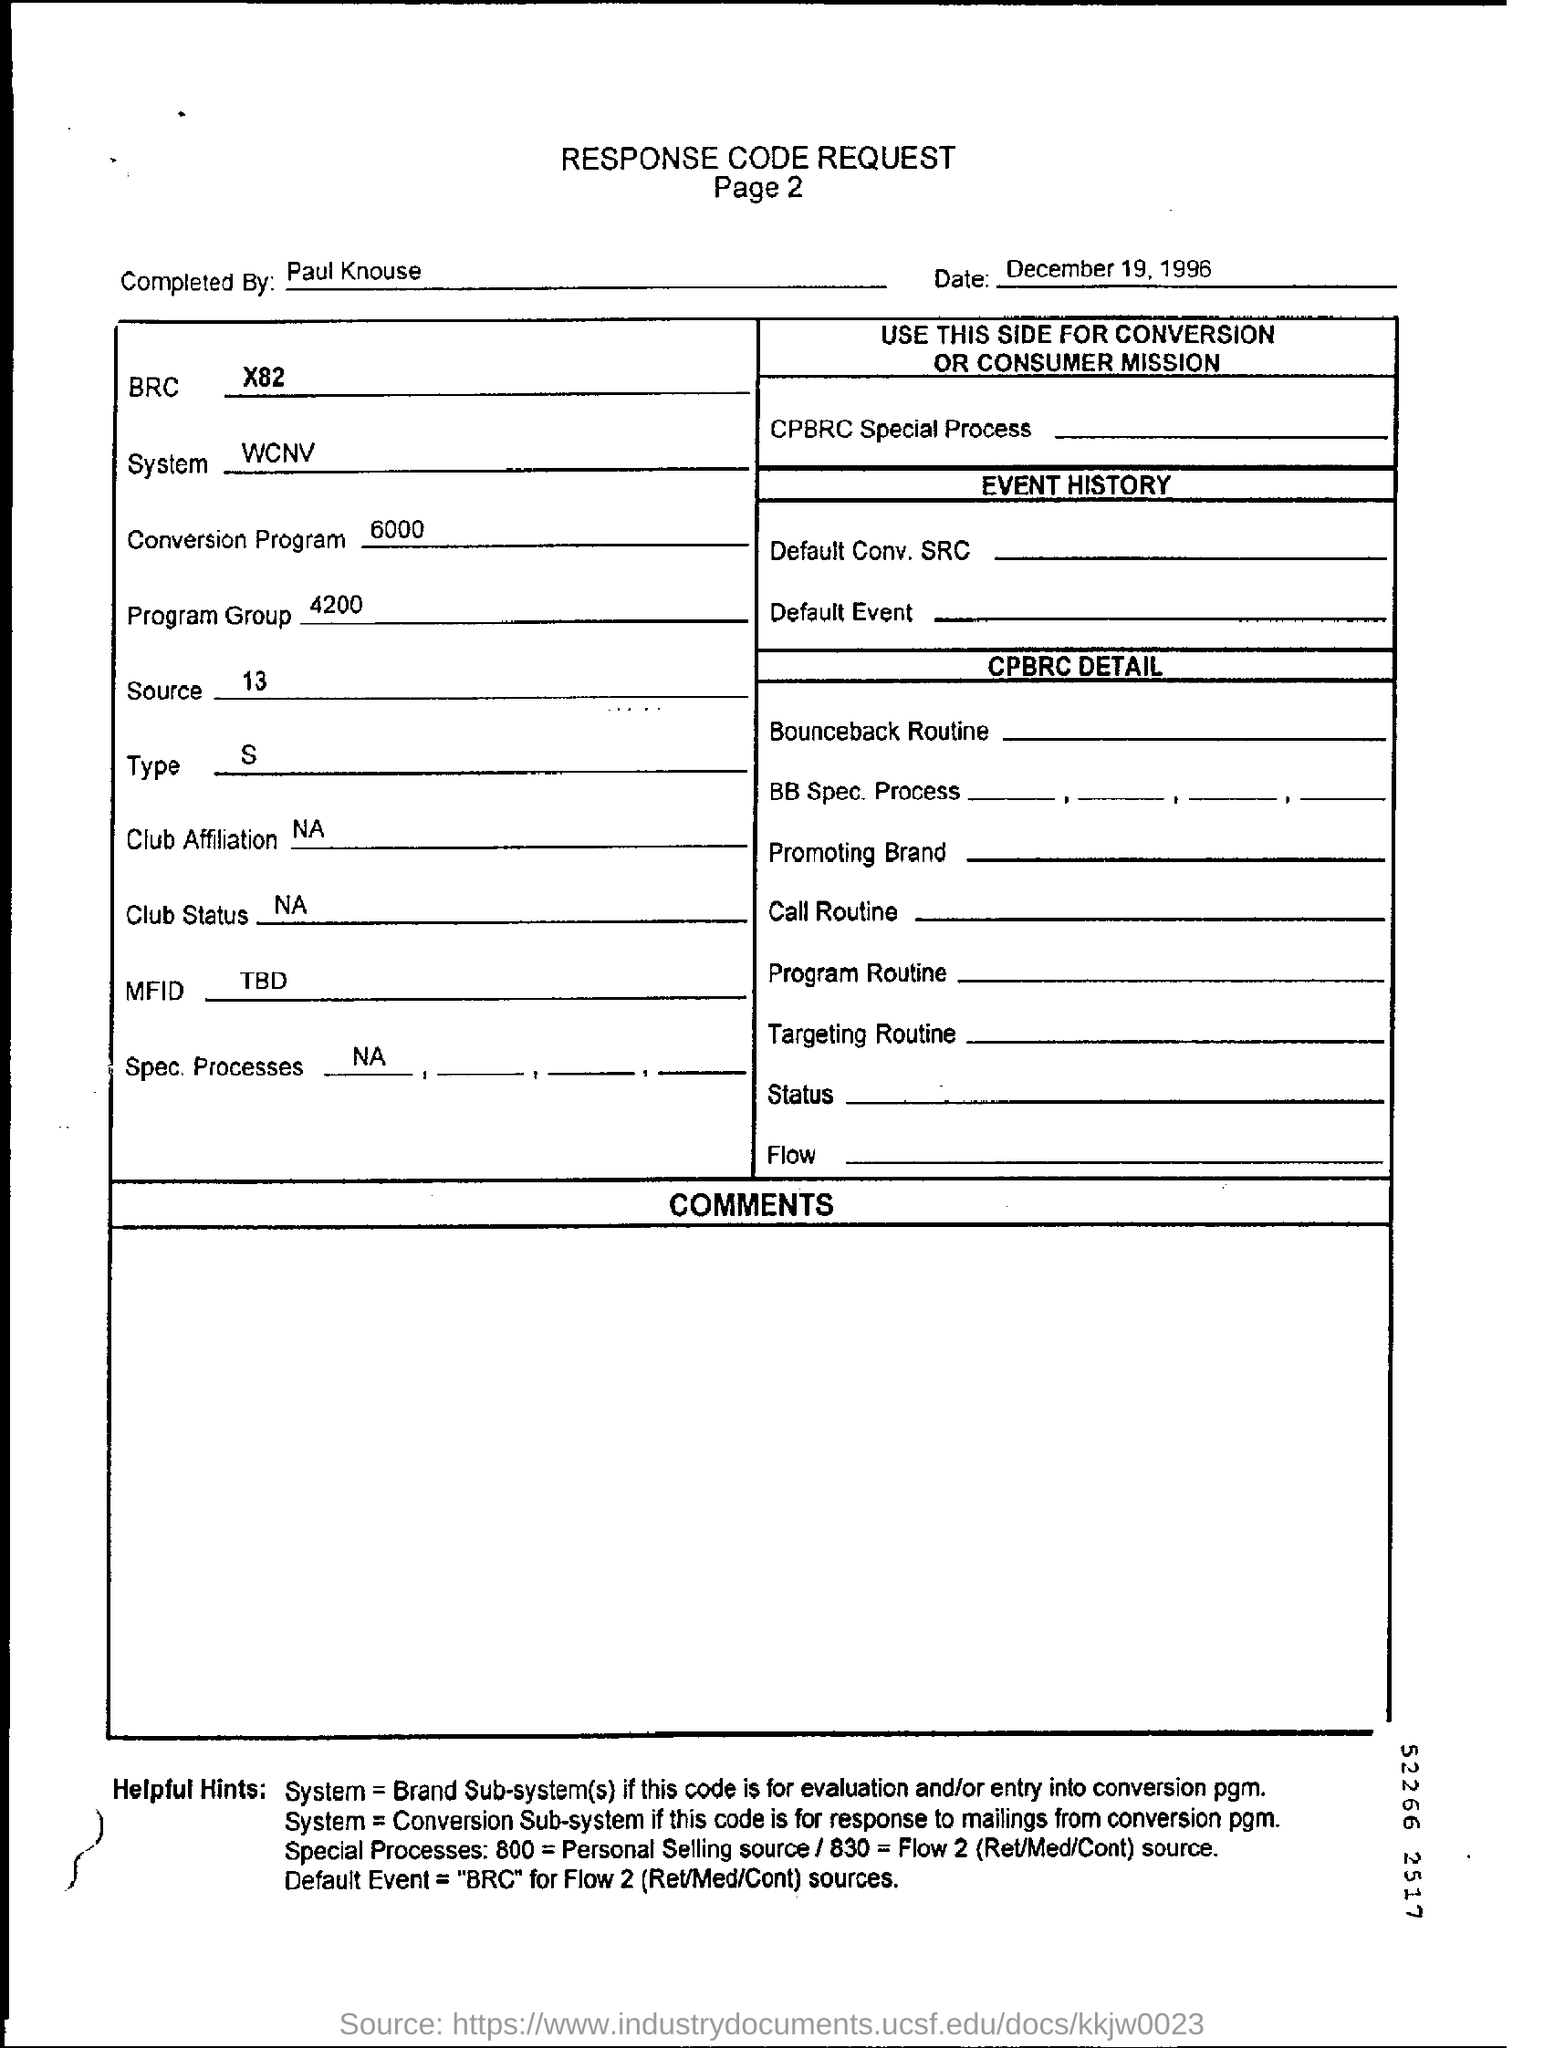Outline some significant characteristics in this image. The program group number is 4200. The response code request form is dated December 19, 1996. The individual who completed the response code request form was Paul Knouse. 